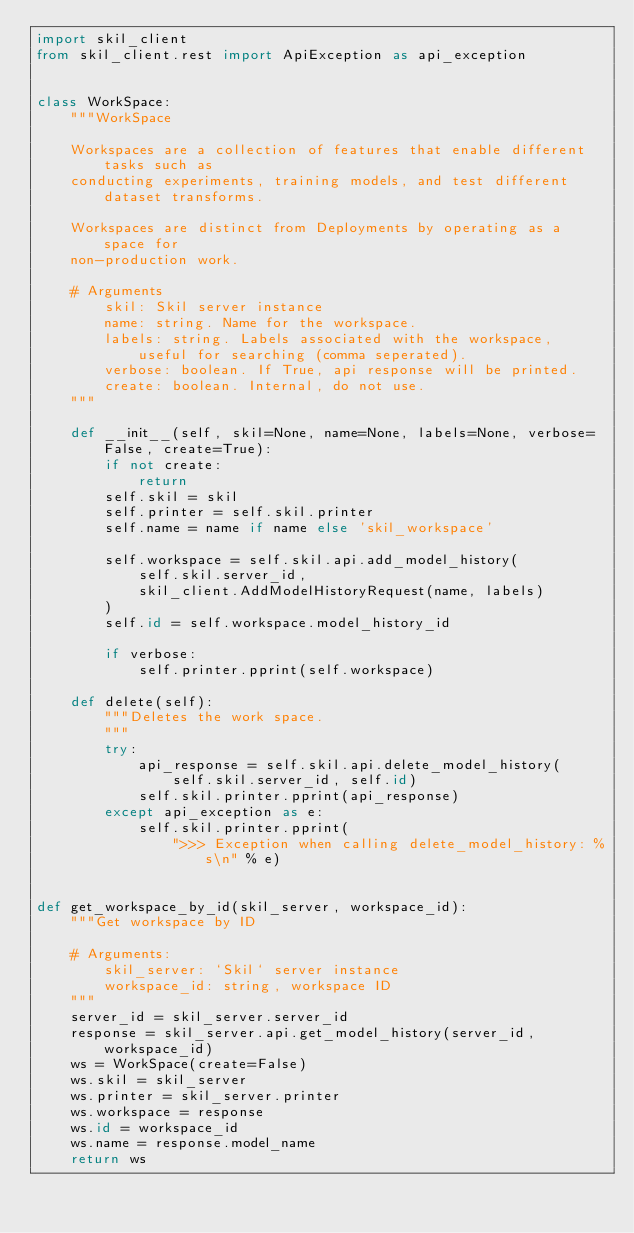<code> <loc_0><loc_0><loc_500><loc_500><_Python_>import skil_client
from skil_client.rest import ApiException as api_exception


class WorkSpace:
    """WorkSpace

    Workspaces are a collection of features that enable different tasks such as
    conducting experiments, training models, and test different dataset transforms.

    Workspaces are distinct from Deployments by operating as a space for 
    non-production work.

    # Arguments
        skil: Skil server instance
        name: string. Name for the workspace.
        labels: string. Labels associated with the workspace, useful for searching (comma seperated).
        verbose: boolean. If True, api response will be printed.
        create: boolean. Internal, do not use.
    """

    def __init__(self, skil=None, name=None, labels=None, verbose=False, create=True):
        if not create:
            return
        self.skil = skil
        self.printer = self.skil.printer
        self.name = name if name else 'skil_workspace'

        self.workspace = self.skil.api.add_model_history(
            self.skil.server_id,
            skil_client.AddModelHistoryRequest(name, labels)
        )
        self.id = self.workspace.model_history_id

        if verbose:
            self.printer.pprint(self.workspace)

    def delete(self):
        """Deletes the work space.
        """
        try:
            api_response = self.skil.api.delete_model_history(
                self.skil.server_id, self.id)
            self.skil.printer.pprint(api_response)
        except api_exception as e:
            self.skil.printer.pprint(
                ">>> Exception when calling delete_model_history: %s\n" % e)


def get_workspace_by_id(skil_server, workspace_id):
    """Get workspace by ID

    # Arguments:
        skil_server: `Skil` server instance
        workspace_id: string, workspace ID
    """
    server_id = skil_server.server_id
    response = skil_server.api.get_model_history(server_id, workspace_id)
    ws = WorkSpace(create=False)
    ws.skil = skil_server
    ws.printer = skil_server.printer
    ws.workspace = response
    ws.id = workspace_id
    ws.name = response.model_name
    return ws
</code> 